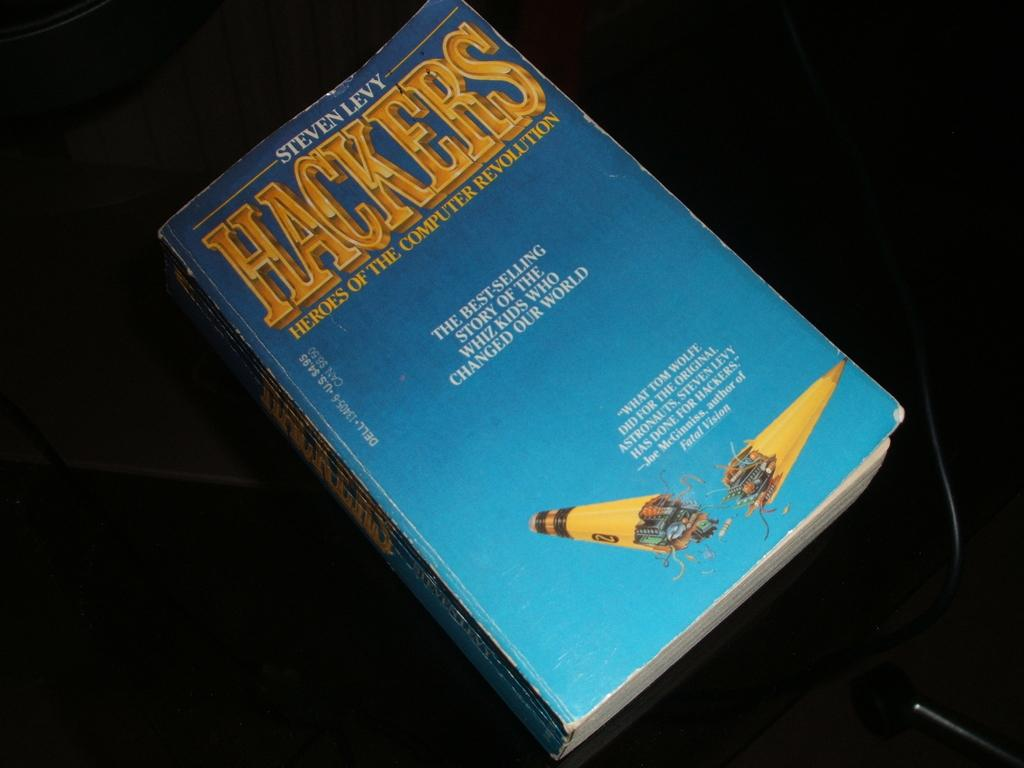Provide a one-sentence caption for the provided image. book with a blue cover called hackers with yellow writing. 